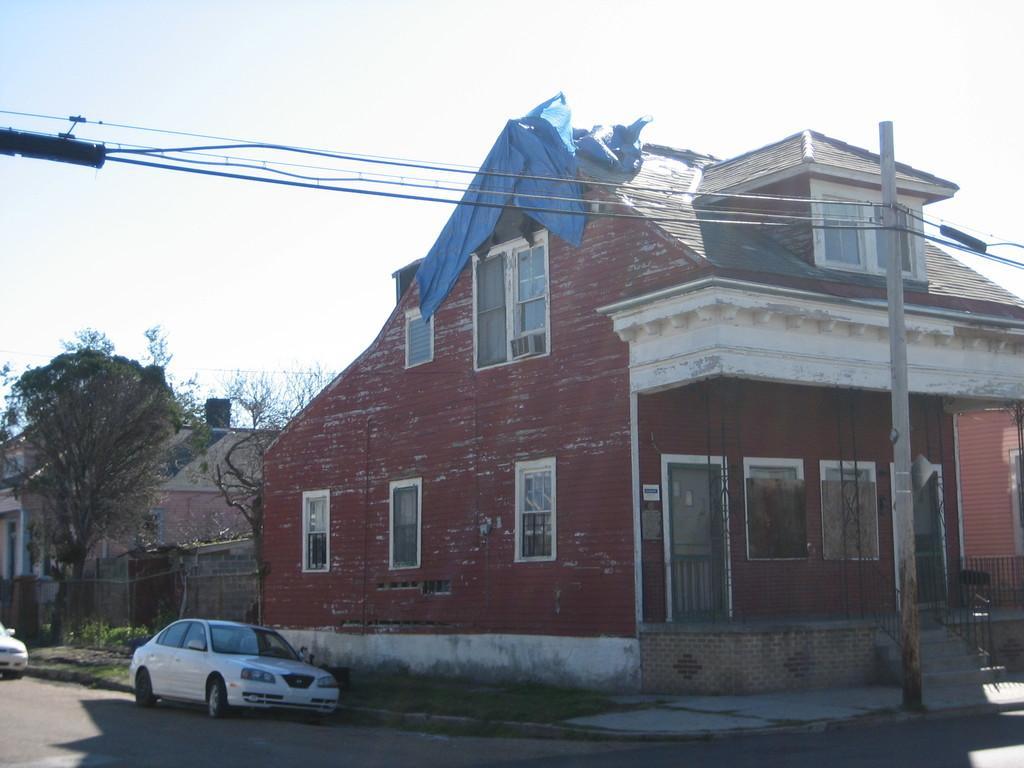Please provide a concise description of this image. In the picture I can see cars parked on the side of the road, I can see houses, poles, wires, trees and the plain sky in the background. 